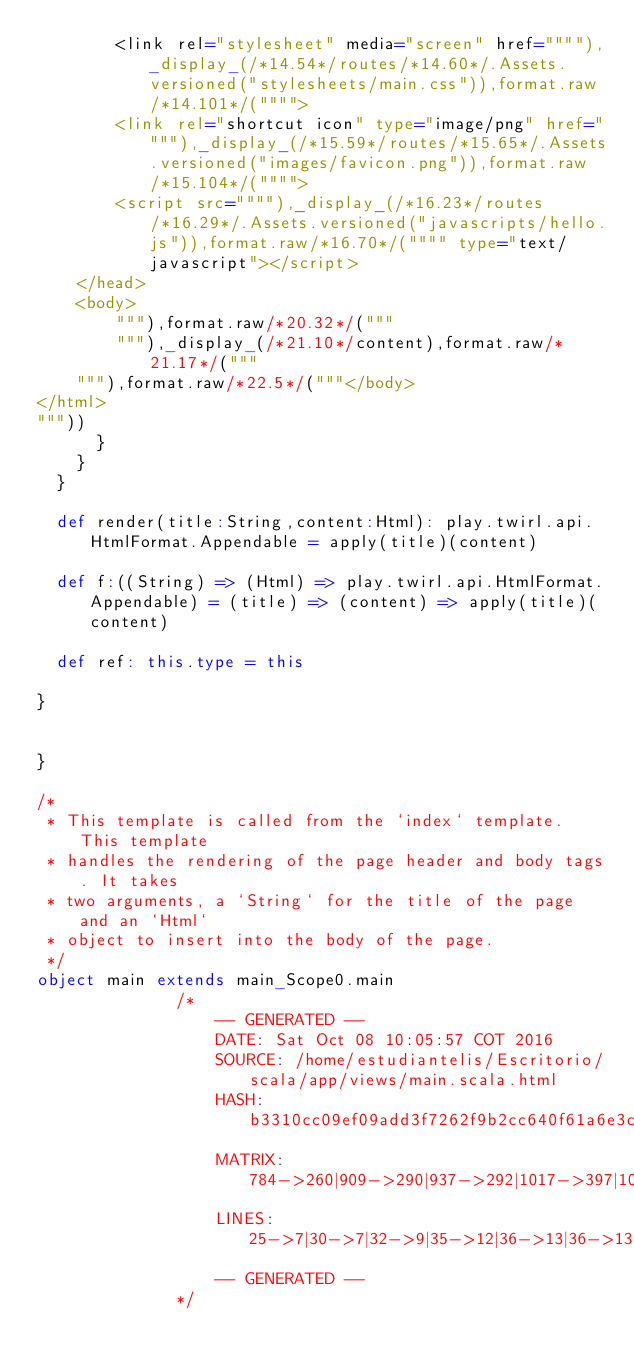Convert code to text. <code><loc_0><loc_0><loc_500><loc_500><_Scala_>        <link rel="stylesheet" media="screen" href=""""),_display_(/*14.54*/routes/*14.60*/.Assets.versioned("stylesheets/main.css")),format.raw/*14.101*/("""">
        <link rel="shortcut icon" type="image/png" href=""""),_display_(/*15.59*/routes/*15.65*/.Assets.versioned("images/favicon.png")),format.raw/*15.104*/("""">
        <script src=""""),_display_(/*16.23*/routes/*16.29*/.Assets.versioned("javascripts/hello.js")),format.raw/*16.70*/("""" type="text/javascript"></script>
    </head>
    <body>
        """),format.raw/*20.32*/("""
        """),_display_(/*21.10*/content),format.raw/*21.17*/("""
    """),format.raw/*22.5*/("""</body>
</html>
"""))
      }
    }
  }

  def render(title:String,content:Html): play.twirl.api.HtmlFormat.Appendable = apply(title)(content)

  def f:((String) => (Html) => play.twirl.api.HtmlFormat.Appendable) = (title) => (content) => apply(title)(content)

  def ref: this.type = this

}


}

/*
 * This template is called from the `index` template. This template
 * handles the rendering of the page header and body tags. It takes
 * two arguments, a `String` for the title of the page and an `Html`
 * object to insert into the body of the page.
 */
object main extends main_Scope0.main
              /*
                  -- GENERATED --
                  DATE: Sat Oct 08 10:05:57 COT 2016
                  SOURCE: /home/estudiantelis/Escritorio/scala/app/views/main.scala.html
                  HASH: b3310cc09ef09add3f7262f9b2cc640f61a6e3c3
                  MATRIX: 784->260|909->290|937->292|1017->397|1053->406|1088->414|1114->419|1203->481|1218->487|1281->528|1369->589|1384->595|1445->634|1497->659|1512->665|1574->706|1668->862|1705->872|1733->879|1765->884
                  LINES: 25->7|30->7|32->9|35->12|36->13|36->13|36->13|37->14|37->14|37->14|38->15|38->15|38->15|39->16|39->16|39->16|42->20|43->21|43->21|44->22
                  -- GENERATED --
              */
          </code> 